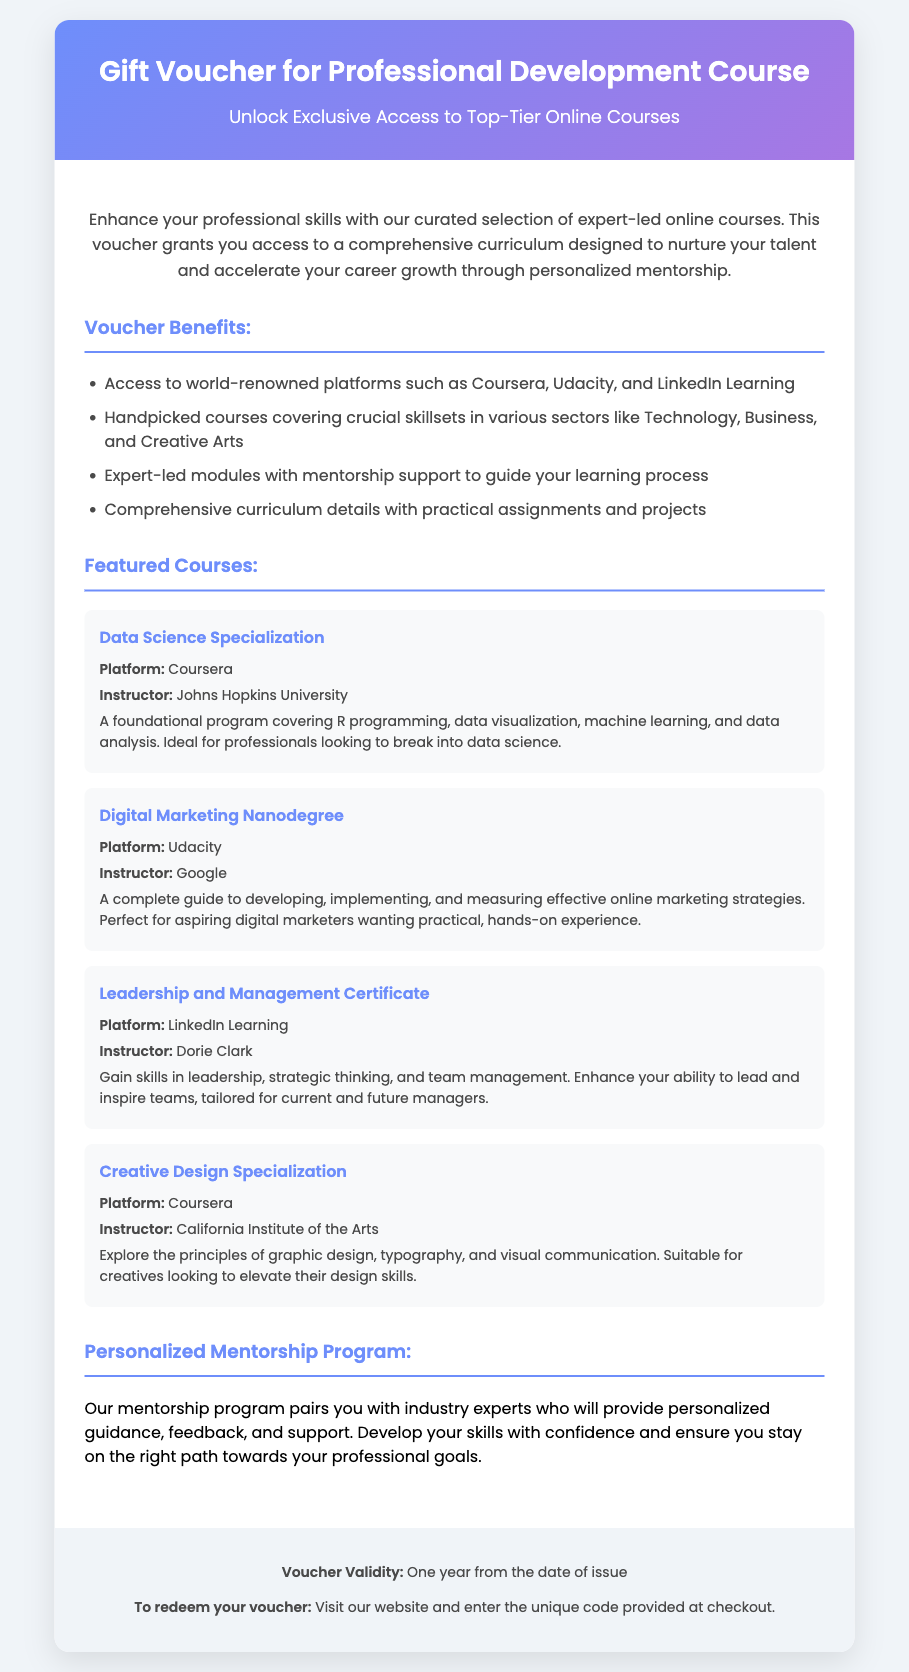What is the title of the voucher? The title of the voucher is found in the header section, which indicates it is a "Gift Voucher for Professional Development Course."
Answer: Gift Voucher for Professional Development Course How long is the voucher valid? The validity period of the voucher is stated in the footer section, specifying it lasts for one year from the date of issue.
Answer: One year Which platform offers the "Data Science Specialization"? The specific platform for the "Data Science Specialization" course is provided in the document under featured courses.
Answer: Coursera Who is the instructor for the "Digital Marketing Nanodegree"? The instructor's name for the "Digital Marketing Nanodegree" course is mentioned in the document, showing the expertise behind the course content.
Answer: Google What is one of the benefits outlined in the voucher? The benefits section lists multiple advantages, including access to world-renowned platforms and expert-led modules with mentorship support.
Answer: Access to world-renowned platforms What kind of support does the mentorship program provide? The document describes the mentorship program as one that offers personalized guidance, feedback, and support to help develop skills effectively.
Answer: Personalized guidance Which sector is NOT mentioned in the offer details? The offer details mention various sectors, and by querying what’s not included, we can deduce based on the provided information.
Answer: Healthcare What is a key focus of the "Leadership and Management Certificate" course? The focus of the certificate course is highlighted in the description, indicating it targets leadership, strategic thinking, and team management skills.
Answer: Leadership, strategic thinking, and team management What is required to redeem the voucher? The footer section explains the redemption process, specifically mentioning entering a unique code at checkout.
Answer: Unique code at checkout 